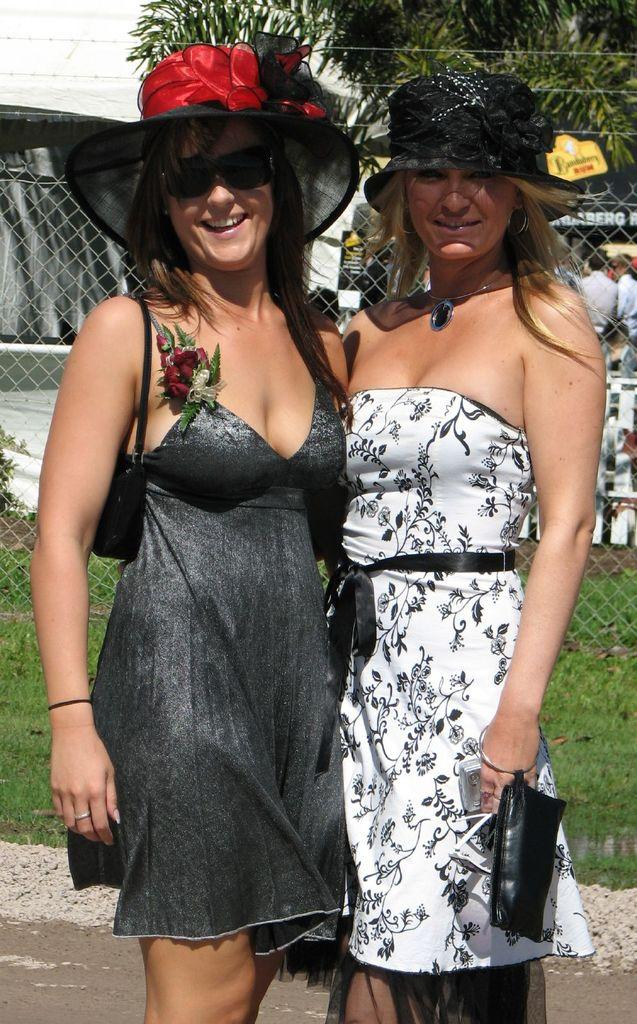How many people are standing on the road in the image? There are two persons standing on the road in the image. What can be seen in the background of the image? In the background of the image, there is grass, fencing, a group of persons, and a building. Can you describe the setting of the image? The image shows two people standing on a road, with a grassy area and fencing in the background, along with a group of people and a building. What is the opinion of the pen on the road in the image? There is no pen present in the image, so it is not possible to determine its opinion. 